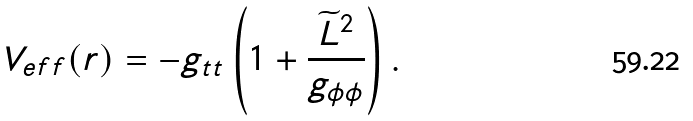<formula> <loc_0><loc_0><loc_500><loc_500>V _ { e f f } ( r ) = - g _ { t t } \left ( 1 + \frac { \widetilde { L } ^ { 2 } } { g _ { \phi \phi } } \right ) .</formula> 